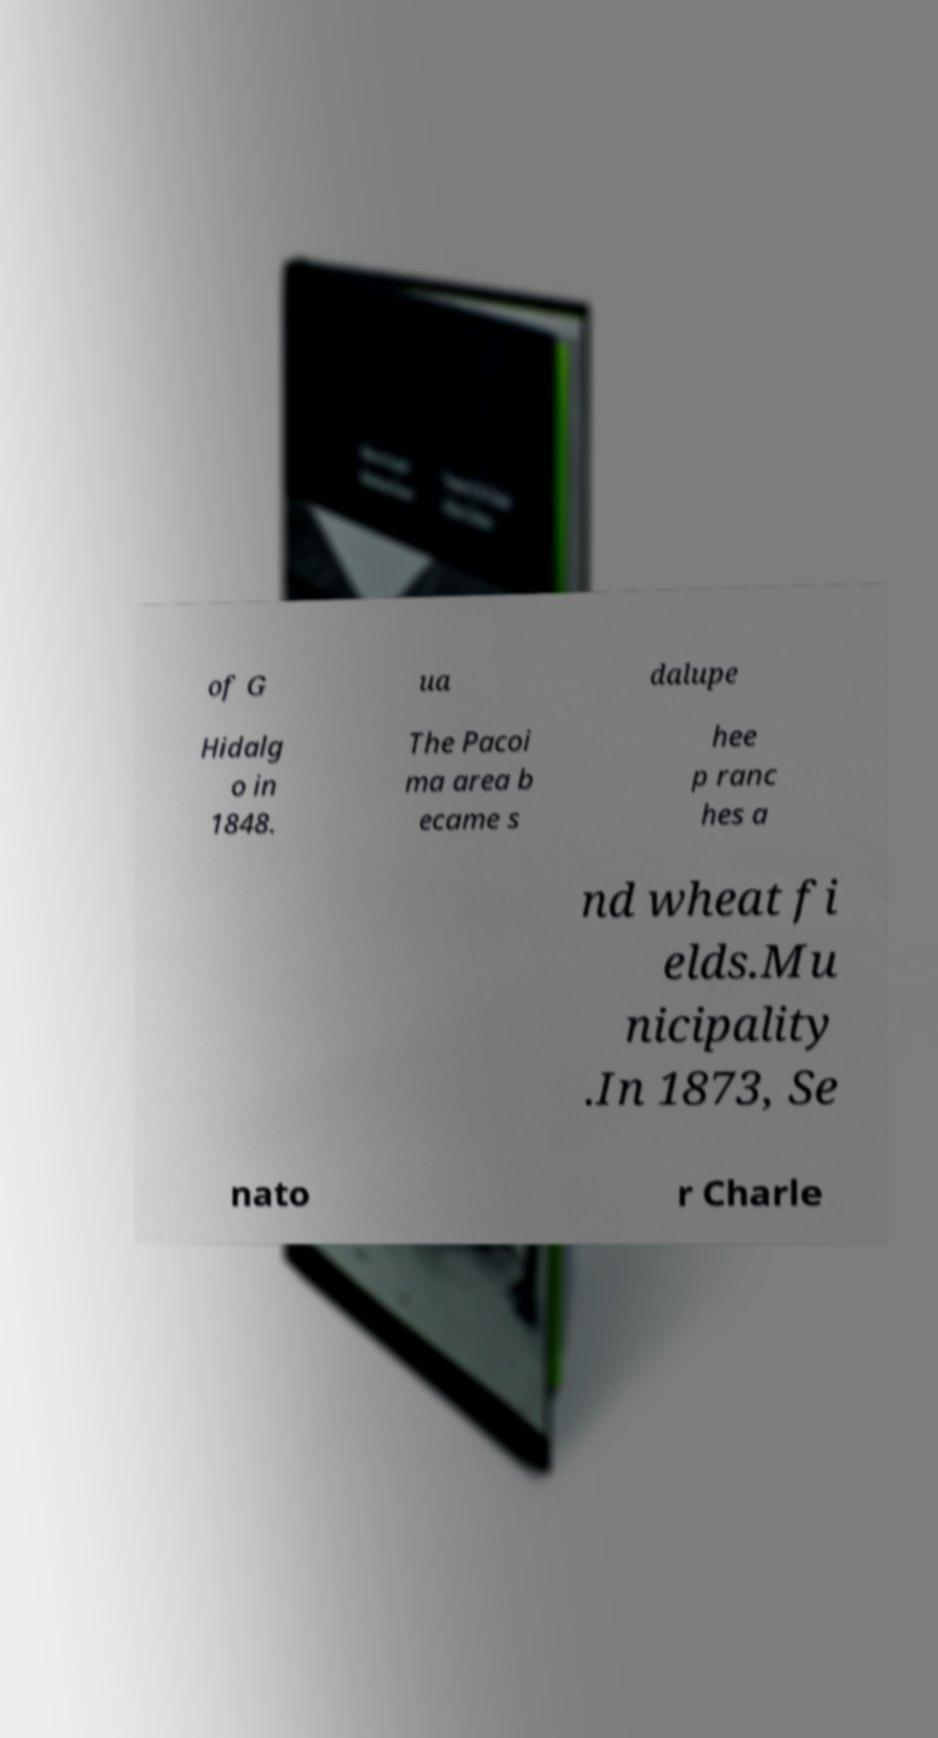There's text embedded in this image that I need extracted. Can you transcribe it verbatim? of G ua dalupe Hidalg o in 1848. The Pacoi ma area b ecame s hee p ranc hes a nd wheat fi elds.Mu nicipality .In 1873, Se nato r Charle 